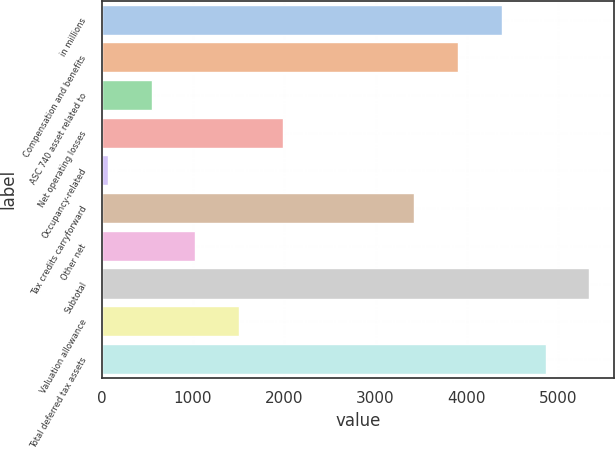Convert chart to OTSL. <chart><loc_0><loc_0><loc_500><loc_500><bar_chart><fcel>in millions<fcel>Compensation and benefits<fcel>ASC 740 asset related to<fcel>Net operating losses<fcel>Occupancy-related<fcel>Tax credits carryforward<fcel>Other net<fcel>Subtotal<fcel>Valuation allowance<fcel>Total deferred tax assets<nl><fcel>4382.5<fcel>3903<fcel>546.5<fcel>1985<fcel>67<fcel>3423.5<fcel>1026<fcel>5341.5<fcel>1505.5<fcel>4862<nl></chart> 